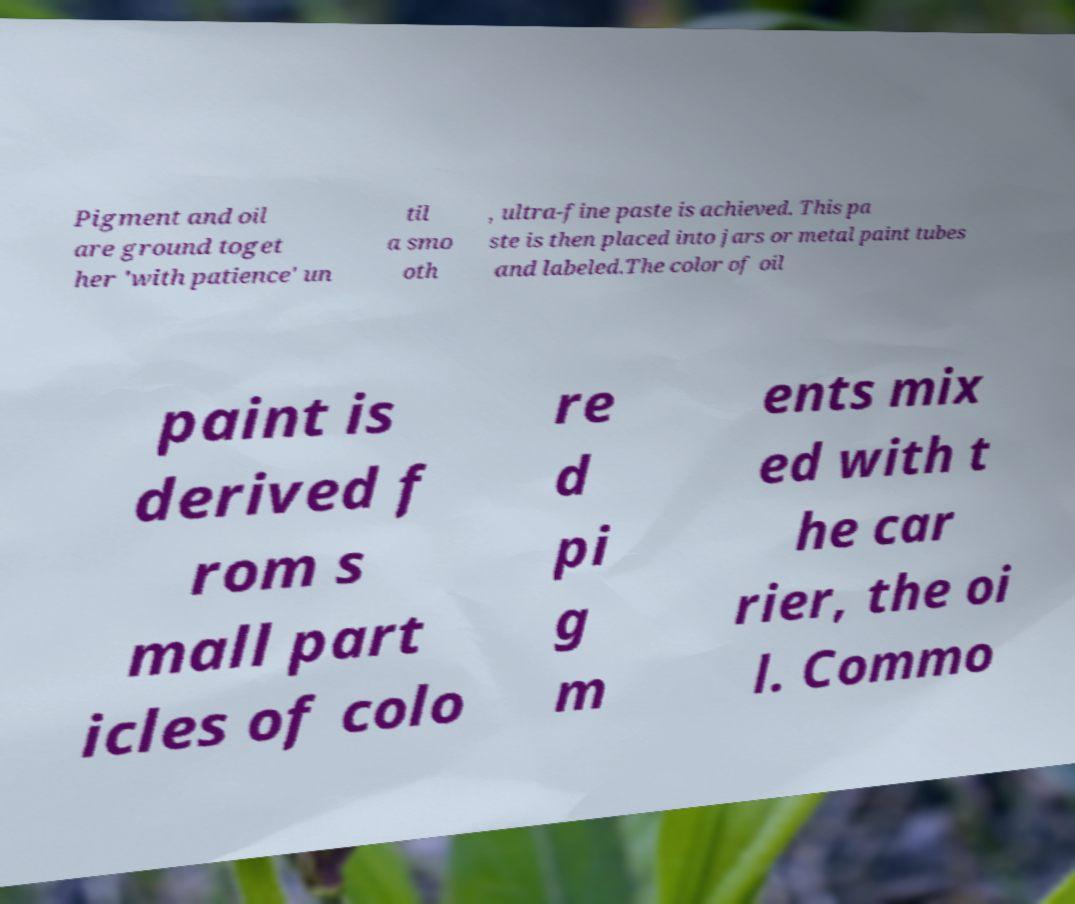Can you accurately transcribe the text from the provided image for me? Pigment and oil are ground toget her 'with patience' un til a smo oth , ultra-fine paste is achieved. This pa ste is then placed into jars or metal paint tubes and labeled.The color of oil paint is derived f rom s mall part icles of colo re d pi g m ents mix ed with t he car rier, the oi l. Commo 